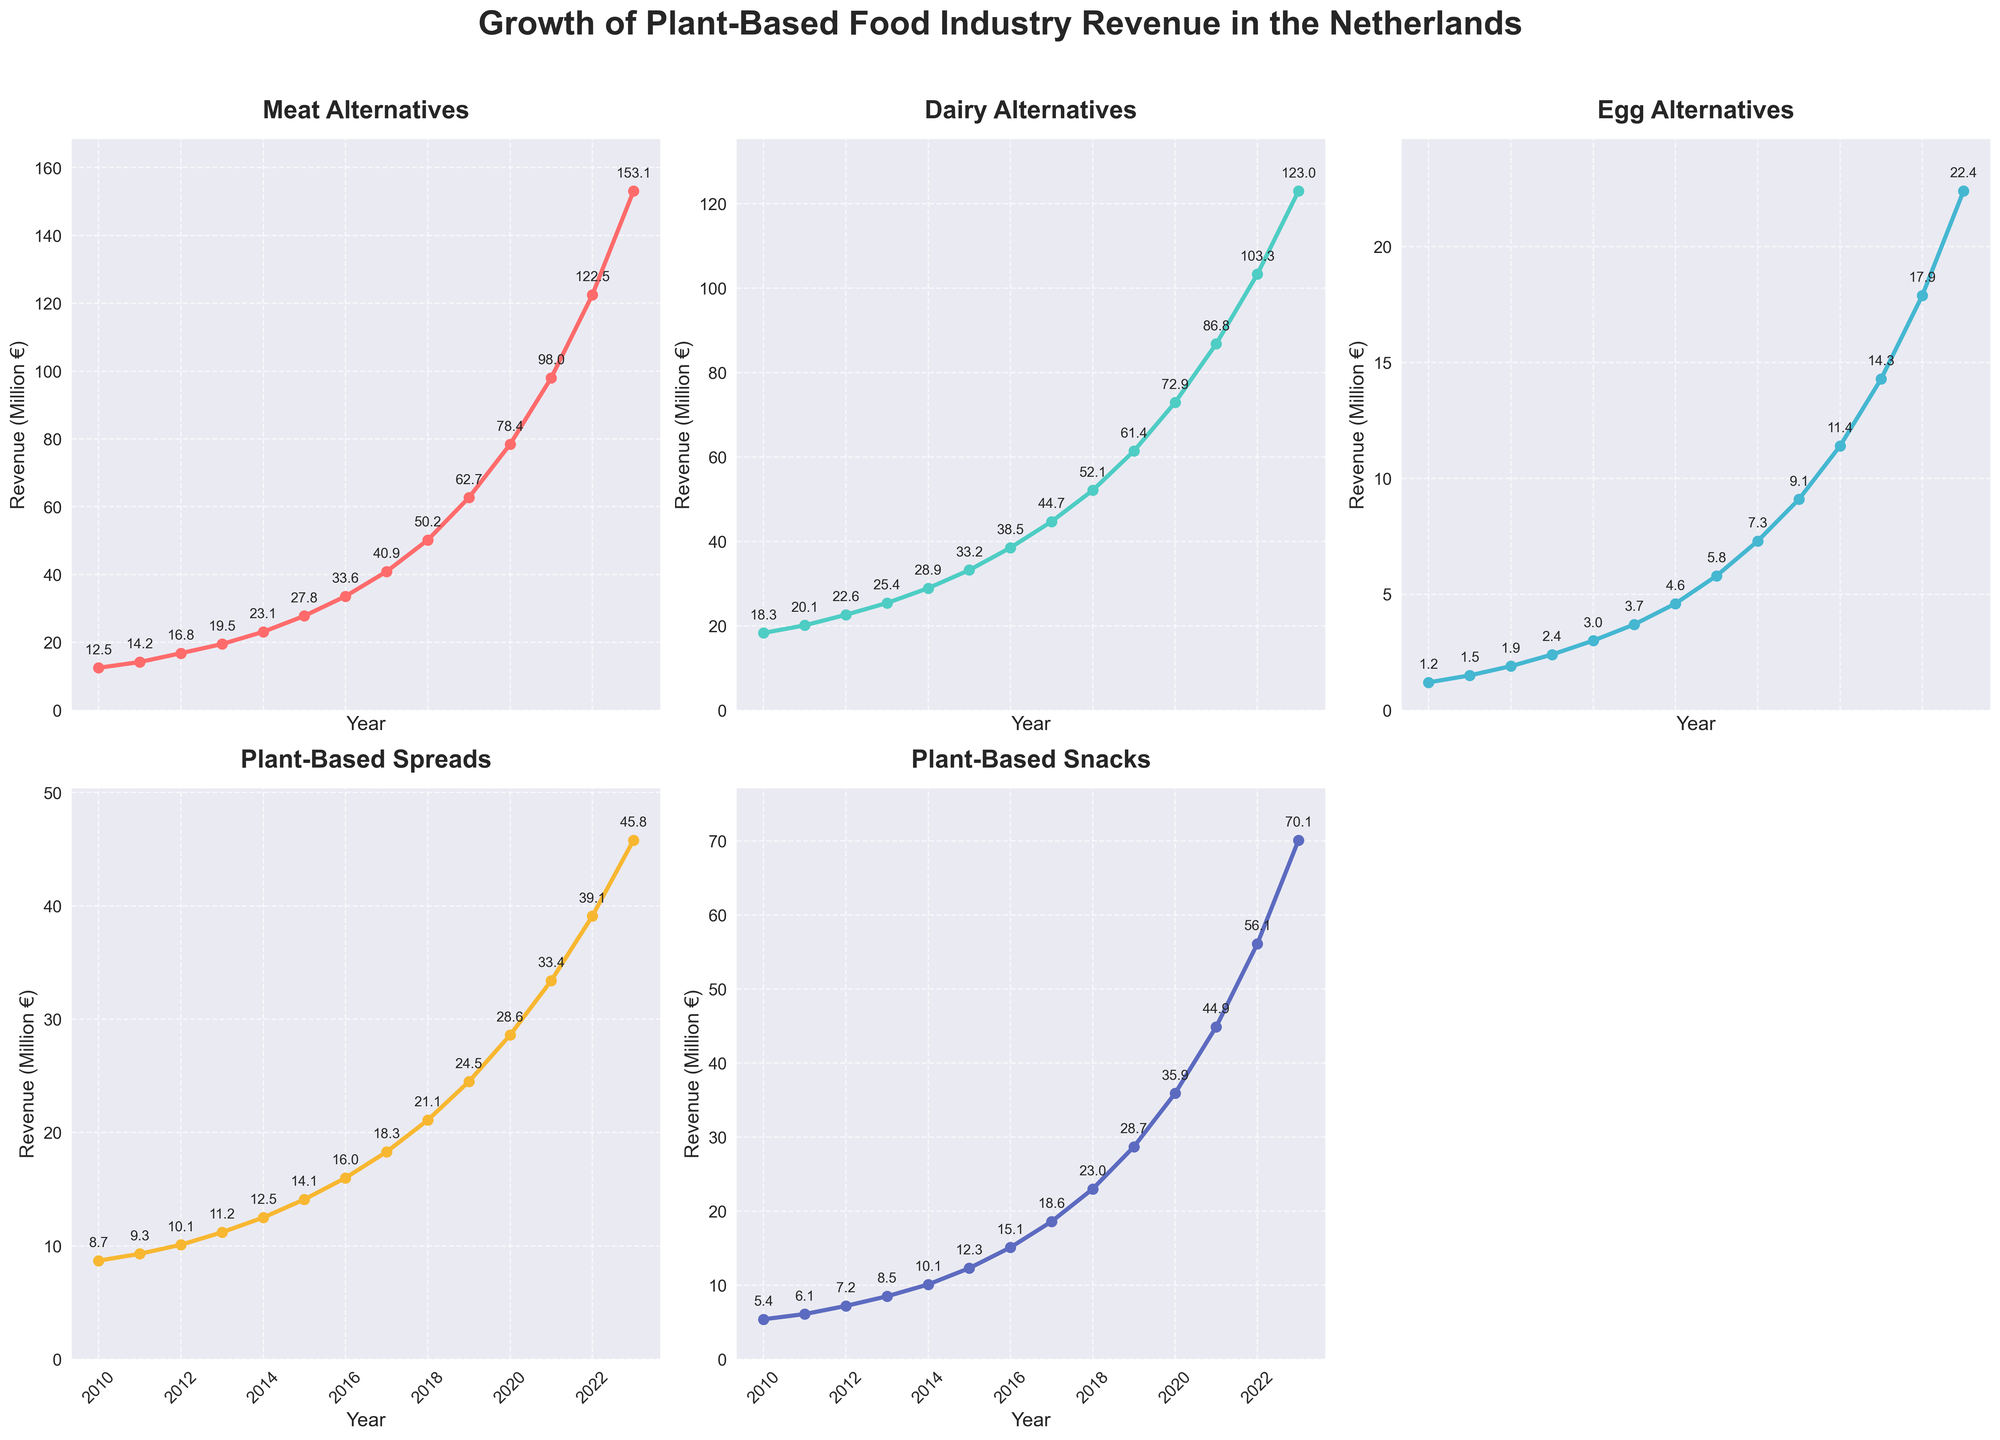What is the total revenue of Meat Alternatives in 2023? In 2023, the Meat Alternatives revenue is indicated on the chart at the highest point of the relevant line, which is labeled as 153.1 million €.
Answer: 153.1 million € Which product category has the highest revenue growth from 2010 to 2023? To determine the category with the highest revenue growth, compare the initial and final values for each category. Meat Alternatives grew from 12.5 million € to 153.1 million €, Dairy Alternatives from 18.3 million € to 123.0 million €, Egg Alternatives from 1.2 million € to 22.4 million €, Plant-Based Spreads from 8.7 million € to 45.8 million €, and Plant-Based Snacks from 5.4 million € to 70.1 million €. The largest growth is in Meat Alternatives.
Answer: Meat Alternatives By how much did the revenue of Dairy Alternatives increase between 2015 and 2020? In 2015, the Dairy Alternatives revenue was 33.2 million € and in 2020 it was 72.9 million €. The increase can be calculated by subtracting the 2015 value from the 2020 value: 72.9 million € - 33.2 million € = 39.7 million €.
Answer: 39.7 million € Which product category had the least revenue in 2010 and what was it? By checking the plot for 2010, we can see that Egg Alternatives had the least revenue at 1.2 million €.
Answer: Egg Alternatives, 1.2 million € Which product saw a more substantial revenue increase from 2018 to 2021, Plant-Based Snacks or Plant-Based Spreads? Comparing the revenue in 2018 and 2021 for both categories: For Plant-Based Snacks, it increased from 23.0 million € to 44.9 million €, which is an increase of 21.9 million €. For Plant-Based Spreads, it increased from 21.1 million € to 33.4 million €, which is an increase of 12.3 million €. Therefore, Plant-Based Snacks saw the more substantial increase.
Answer: Plant-Based Snacks What was the average revenue of Egg Alternatives from 2010 to 2023? The revenues for Egg Alternatives from 2010 to 2023 are 1.2, 1.5, 1.9, 2.4, 3.0, 3.7, 4.6, 5.8, 7.3, 9.1, 11.4, 14.3, 17.9, and 22.4 million €. To find the average, sum up all values and divide by the number of years: (1.2 + 1.5 + 1.9 + 2.4 + 3.0 + 3.7 + 4.6 + 5.8 + 7.3 + 9.1 + 11.4 + 14.3 + 17.9 + 22.4) / 14 ≈ 8.14 million €.
Answer: 8.14 million € What trend is observed in Plant-Based Spreads from 2010 to 2023? Observing the line for Plant-Based Spreads, it consistently increases every year from 8.7 million € in 2010 to 45.8 million € in 2023, indicating a steady upward trend.
Answer: Steady upward trend 